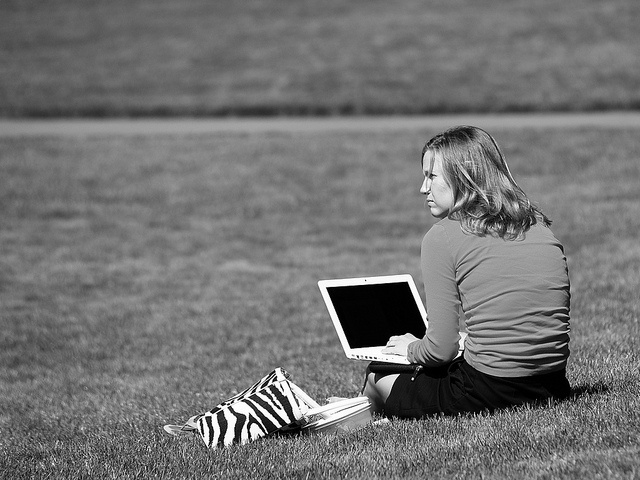Describe the objects in this image and their specific colors. I can see people in gray, darkgray, black, and lightgray tones, laptop in gray, black, white, and darkgray tones, and backpack in gray, white, black, and darkgray tones in this image. 